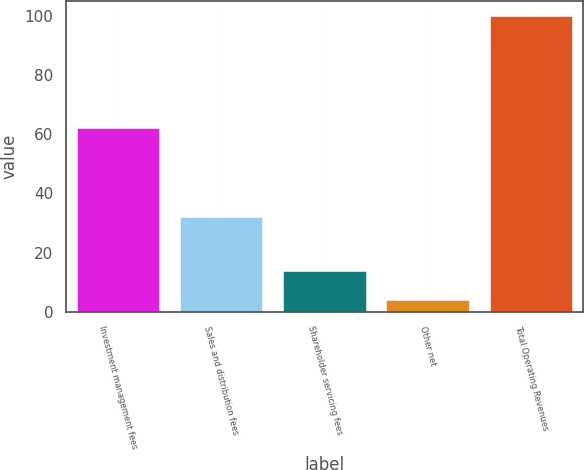<chart> <loc_0><loc_0><loc_500><loc_500><bar_chart><fcel>Investment management fees<fcel>Sales and distribution fees<fcel>Shareholder servicing fees<fcel>Other net<fcel>Total Operating Revenues<nl><fcel>62<fcel>32<fcel>13.63<fcel>4.03<fcel>100<nl></chart> 